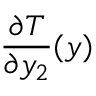Convert formula to latex. <formula><loc_0><loc_0><loc_500><loc_500>\frac { \partial T } { \partial y _ { 2 } } ( y )</formula> 